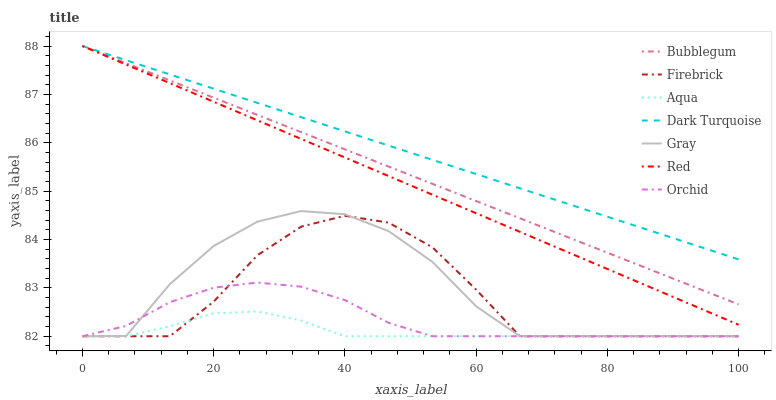Does Aqua have the minimum area under the curve?
Answer yes or no. Yes. Does Dark Turquoise have the maximum area under the curve?
Answer yes or no. Yes. Does Firebrick have the minimum area under the curve?
Answer yes or no. No. Does Firebrick have the maximum area under the curve?
Answer yes or no. No. Is Dark Turquoise the smoothest?
Answer yes or no. Yes. Is Gray the roughest?
Answer yes or no. Yes. Is Firebrick the smoothest?
Answer yes or no. No. Is Firebrick the roughest?
Answer yes or no. No. Does Gray have the lowest value?
Answer yes or no. Yes. Does Dark Turquoise have the lowest value?
Answer yes or no. No. Does Red have the highest value?
Answer yes or no. Yes. Does Firebrick have the highest value?
Answer yes or no. No. Is Aqua less than Bubblegum?
Answer yes or no. Yes. Is Bubblegum greater than Gray?
Answer yes or no. Yes. Does Firebrick intersect Gray?
Answer yes or no. Yes. Is Firebrick less than Gray?
Answer yes or no. No. Is Firebrick greater than Gray?
Answer yes or no. No. Does Aqua intersect Bubblegum?
Answer yes or no. No. 